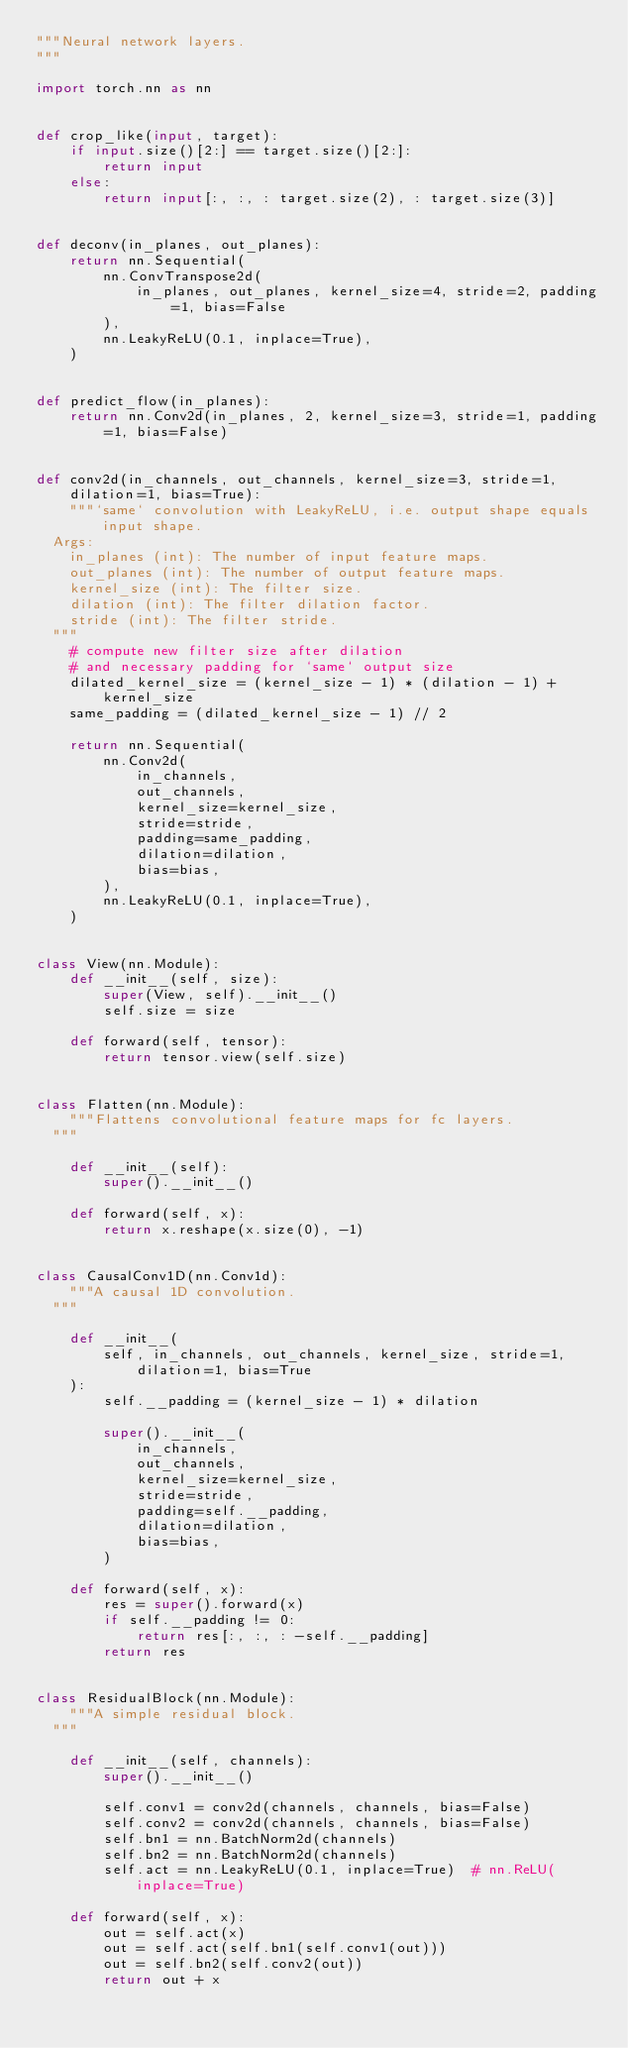<code> <loc_0><loc_0><loc_500><loc_500><_Python_>"""Neural network layers.
"""

import torch.nn as nn


def crop_like(input, target):
    if input.size()[2:] == target.size()[2:]:
        return input
    else:
        return input[:, :, : target.size(2), : target.size(3)]


def deconv(in_planes, out_planes):
    return nn.Sequential(
        nn.ConvTranspose2d(
            in_planes, out_planes, kernel_size=4, stride=2, padding=1, bias=False
        ),
        nn.LeakyReLU(0.1, inplace=True),
    )


def predict_flow(in_planes):
    return nn.Conv2d(in_planes, 2, kernel_size=3, stride=1, padding=1, bias=False)


def conv2d(in_channels, out_channels, kernel_size=3, stride=1, dilation=1, bias=True):
    """`same` convolution with LeakyReLU, i.e. output shape equals input shape.
  Args:
    in_planes (int): The number of input feature maps.
    out_planes (int): The number of output feature maps.
    kernel_size (int): The filter size.
    dilation (int): The filter dilation factor.
    stride (int): The filter stride.
  """
    # compute new filter size after dilation
    # and necessary padding for `same` output size
    dilated_kernel_size = (kernel_size - 1) * (dilation - 1) + kernel_size
    same_padding = (dilated_kernel_size - 1) // 2

    return nn.Sequential(
        nn.Conv2d(
            in_channels,
            out_channels,
            kernel_size=kernel_size,
            stride=stride,
            padding=same_padding,
            dilation=dilation,
            bias=bias,
        ),
        nn.LeakyReLU(0.1, inplace=True),
    )


class View(nn.Module):
    def __init__(self, size):
        super(View, self).__init__()
        self.size = size

    def forward(self, tensor):
        return tensor.view(self.size)


class Flatten(nn.Module):
    """Flattens convolutional feature maps for fc layers.
  """

    def __init__(self):
        super().__init__()

    def forward(self, x):
        return x.reshape(x.size(0), -1)


class CausalConv1D(nn.Conv1d):
    """A causal 1D convolution.
  """

    def __init__(
        self, in_channels, out_channels, kernel_size, stride=1, dilation=1, bias=True
    ):
        self.__padding = (kernel_size - 1) * dilation

        super().__init__(
            in_channels,
            out_channels,
            kernel_size=kernel_size,
            stride=stride,
            padding=self.__padding,
            dilation=dilation,
            bias=bias,
        )

    def forward(self, x):
        res = super().forward(x)
        if self.__padding != 0:
            return res[:, :, : -self.__padding]
        return res


class ResidualBlock(nn.Module):
    """A simple residual block.
  """

    def __init__(self, channels):
        super().__init__()

        self.conv1 = conv2d(channels, channels, bias=False)
        self.conv2 = conv2d(channels, channels, bias=False)
        self.bn1 = nn.BatchNorm2d(channels)
        self.bn2 = nn.BatchNorm2d(channels)
        self.act = nn.LeakyReLU(0.1, inplace=True)  # nn.ReLU(inplace=True)

    def forward(self, x):
        out = self.act(x)
        out = self.act(self.bn1(self.conv1(out)))
        out = self.bn2(self.conv2(out))
        return out + x
</code> 